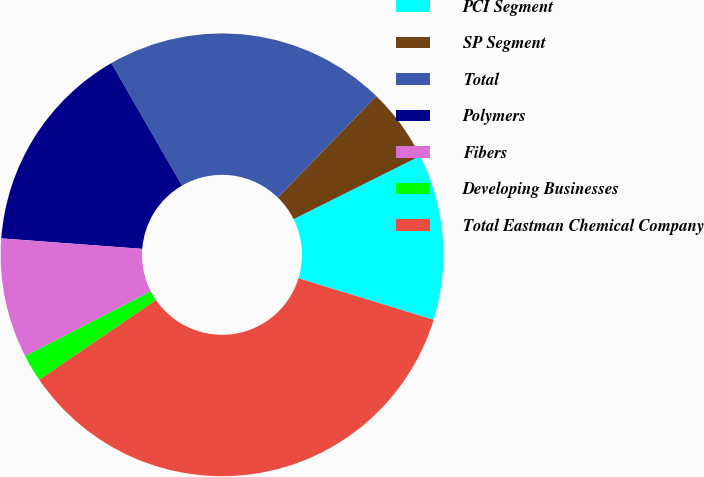Convert chart to OTSL. <chart><loc_0><loc_0><loc_500><loc_500><pie_chart><fcel>PCI Segment<fcel>SP Segment<fcel>Total<fcel>Polymers<fcel>Fibers<fcel>Developing Businesses<fcel>Total Eastman Chemical Company<nl><fcel>12.11%<fcel>5.36%<fcel>20.61%<fcel>15.48%<fcel>8.74%<fcel>1.99%<fcel>35.71%<nl></chart> 